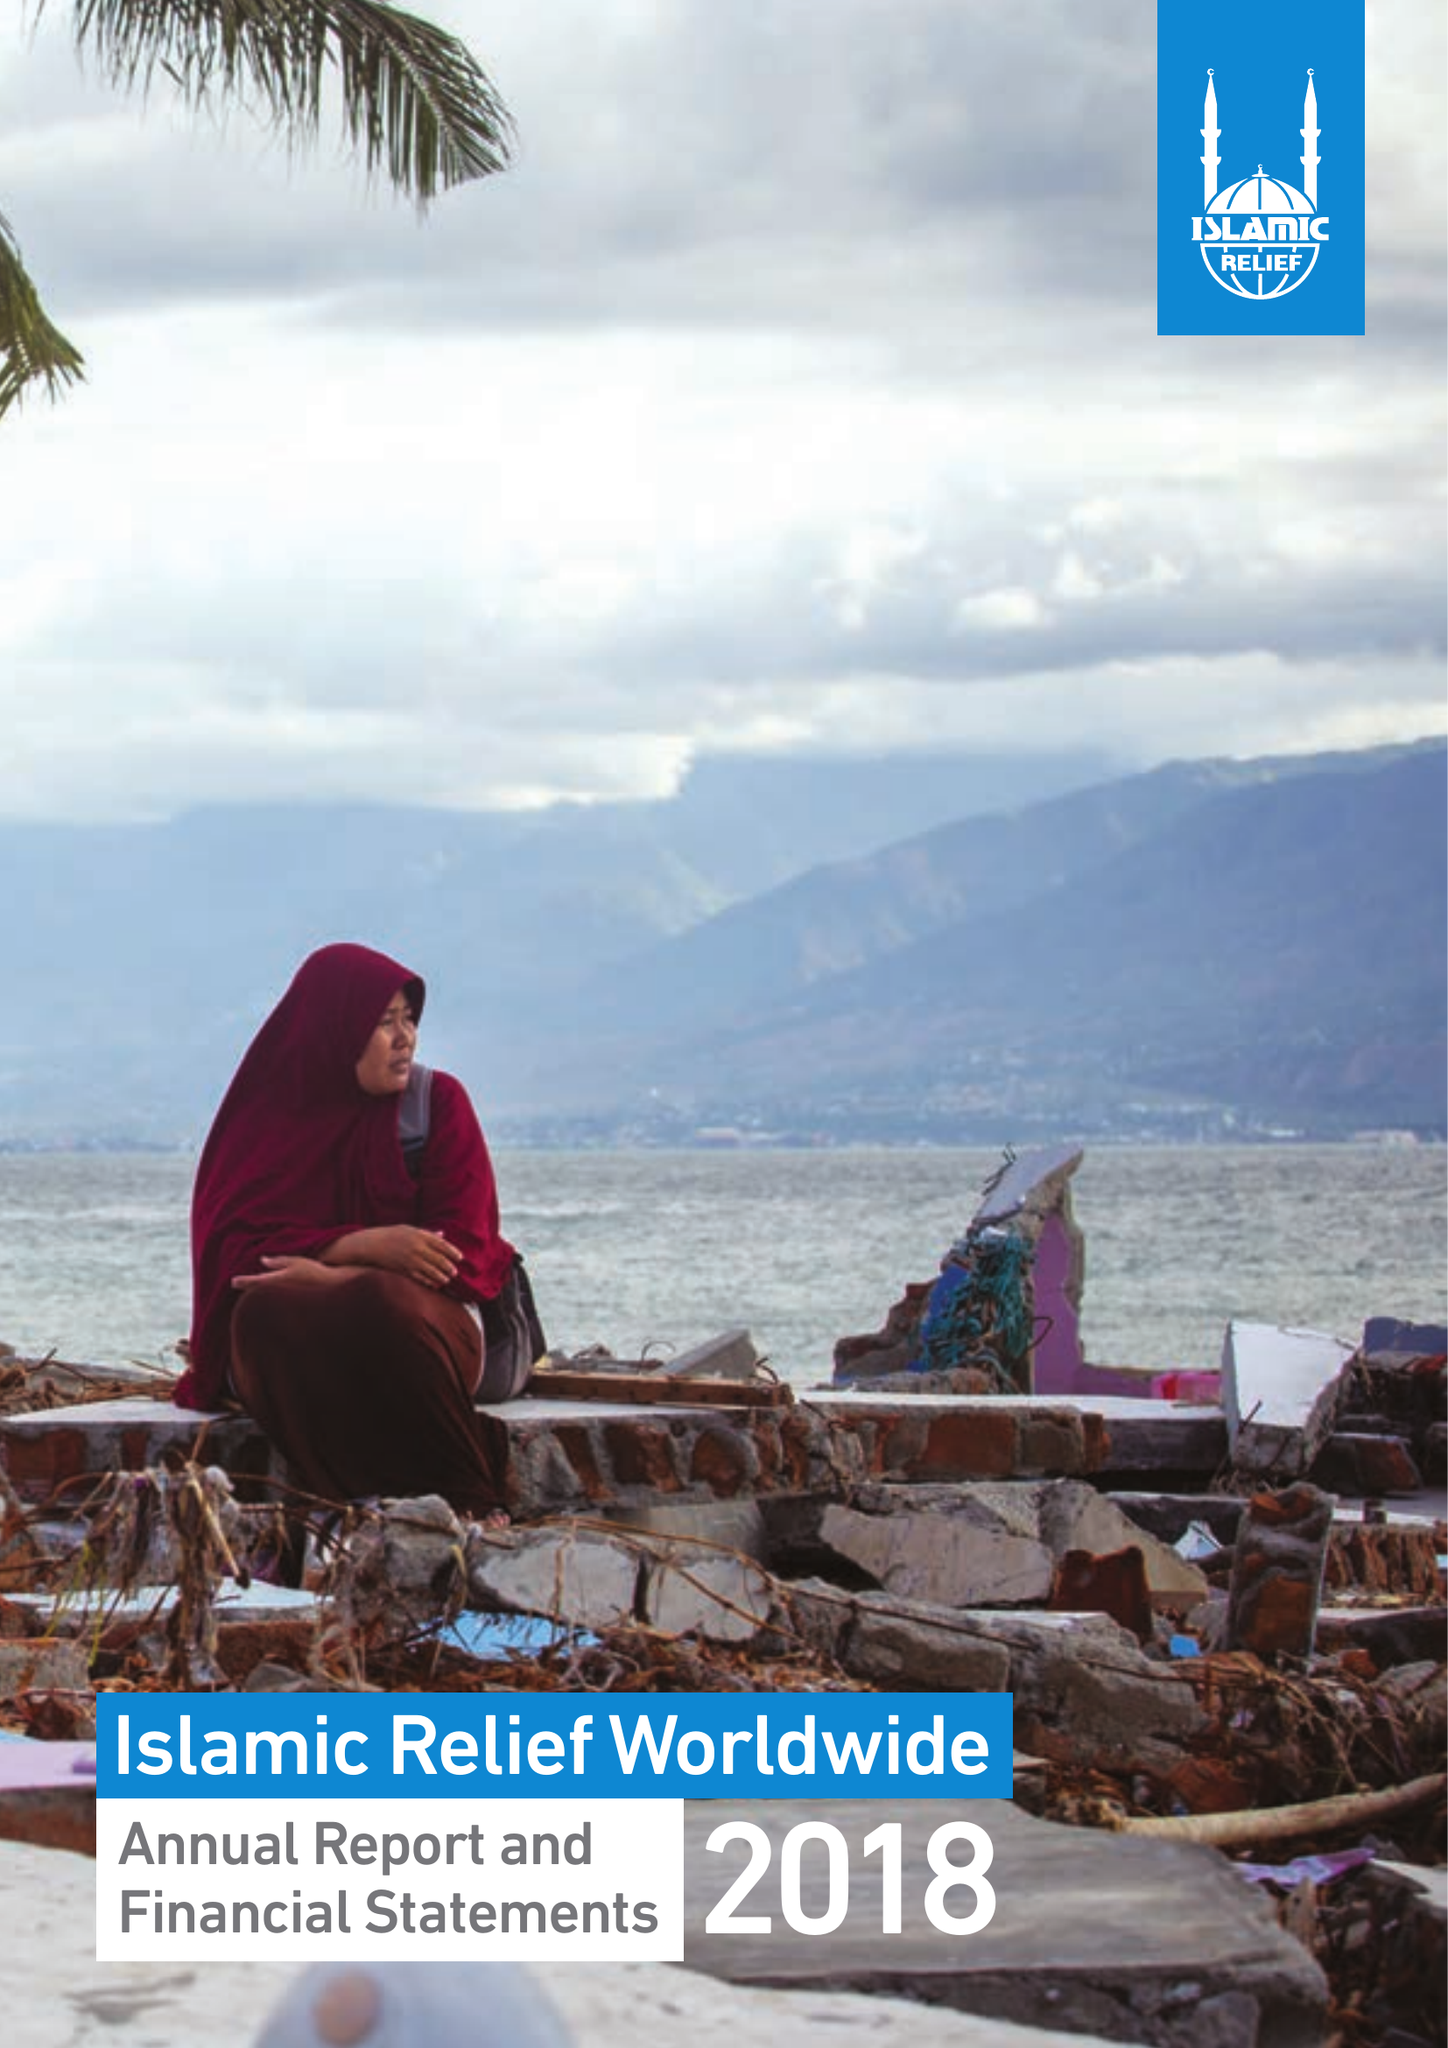What is the value for the charity_name?
Answer the question using a single word or phrase. Islamic Relief Worldwide 